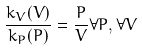<formula> <loc_0><loc_0><loc_500><loc_500>\frac { k _ { V } ( V ) } { k _ { P } ( P ) } = \frac { P } { V } \forall P , \forall V</formula> 